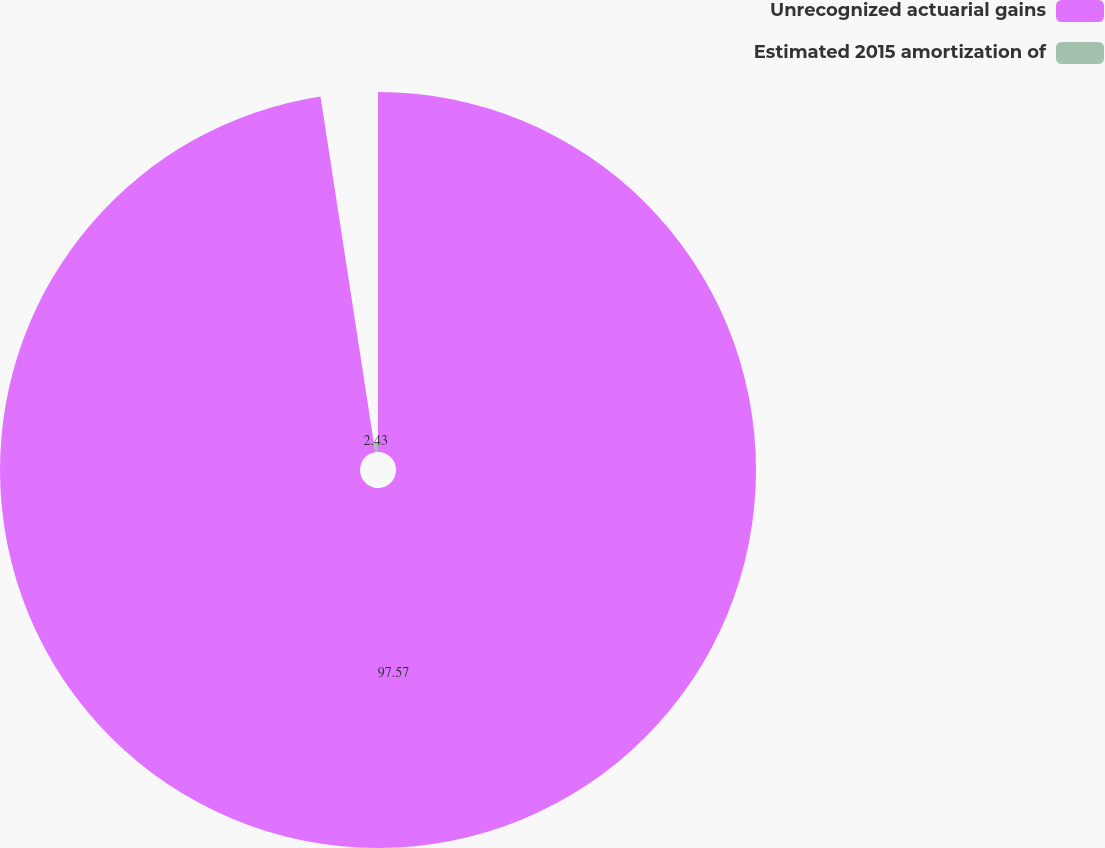Convert chart. <chart><loc_0><loc_0><loc_500><loc_500><pie_chart><fcel>Unrecognized actuarial gains<fcel>Estimated 2015 amortization of<nl><fcel>97.57%<fcel>2.43%<nl></chart> 